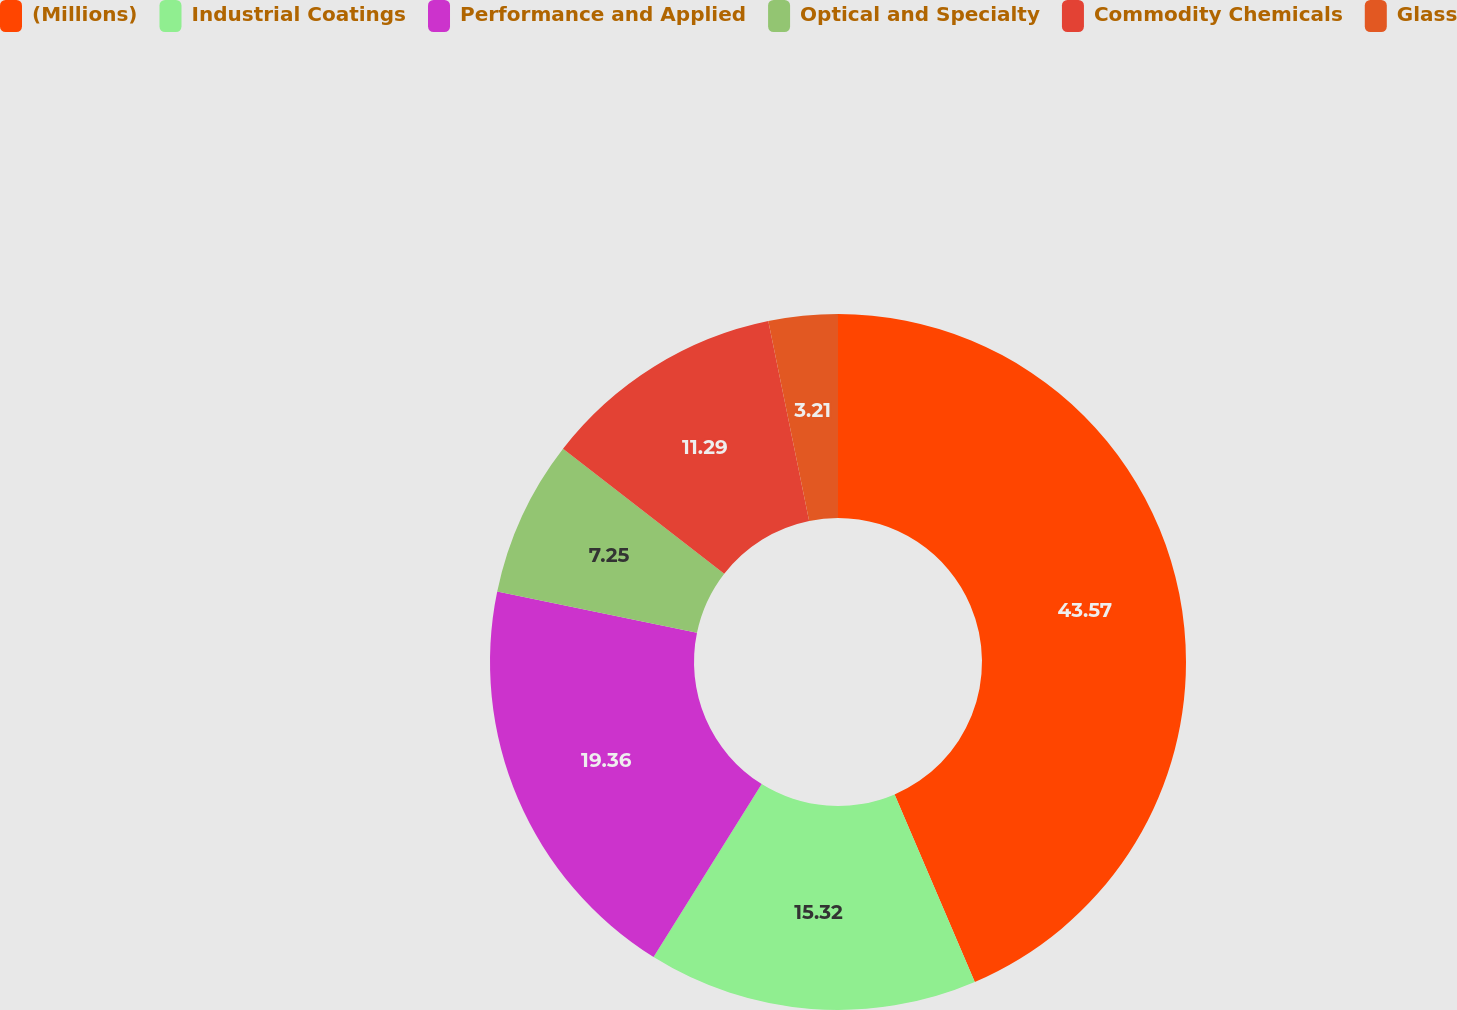<chart> <loc_0><loc_0><loc_500><loc_500><pie_chart><fcel>(Millions)<fcel>Industrial Coatings<fcel>Performance and Applied<fcel>Optical and Specialty<fcel>Commodity Chemicals<fcel>Glass<nl><fcel>43.57%<fcel>15.32%<fcel>19.36%<fcel>7.25%<fcel>11.29%<fcel>3.21%<nl></chart> 